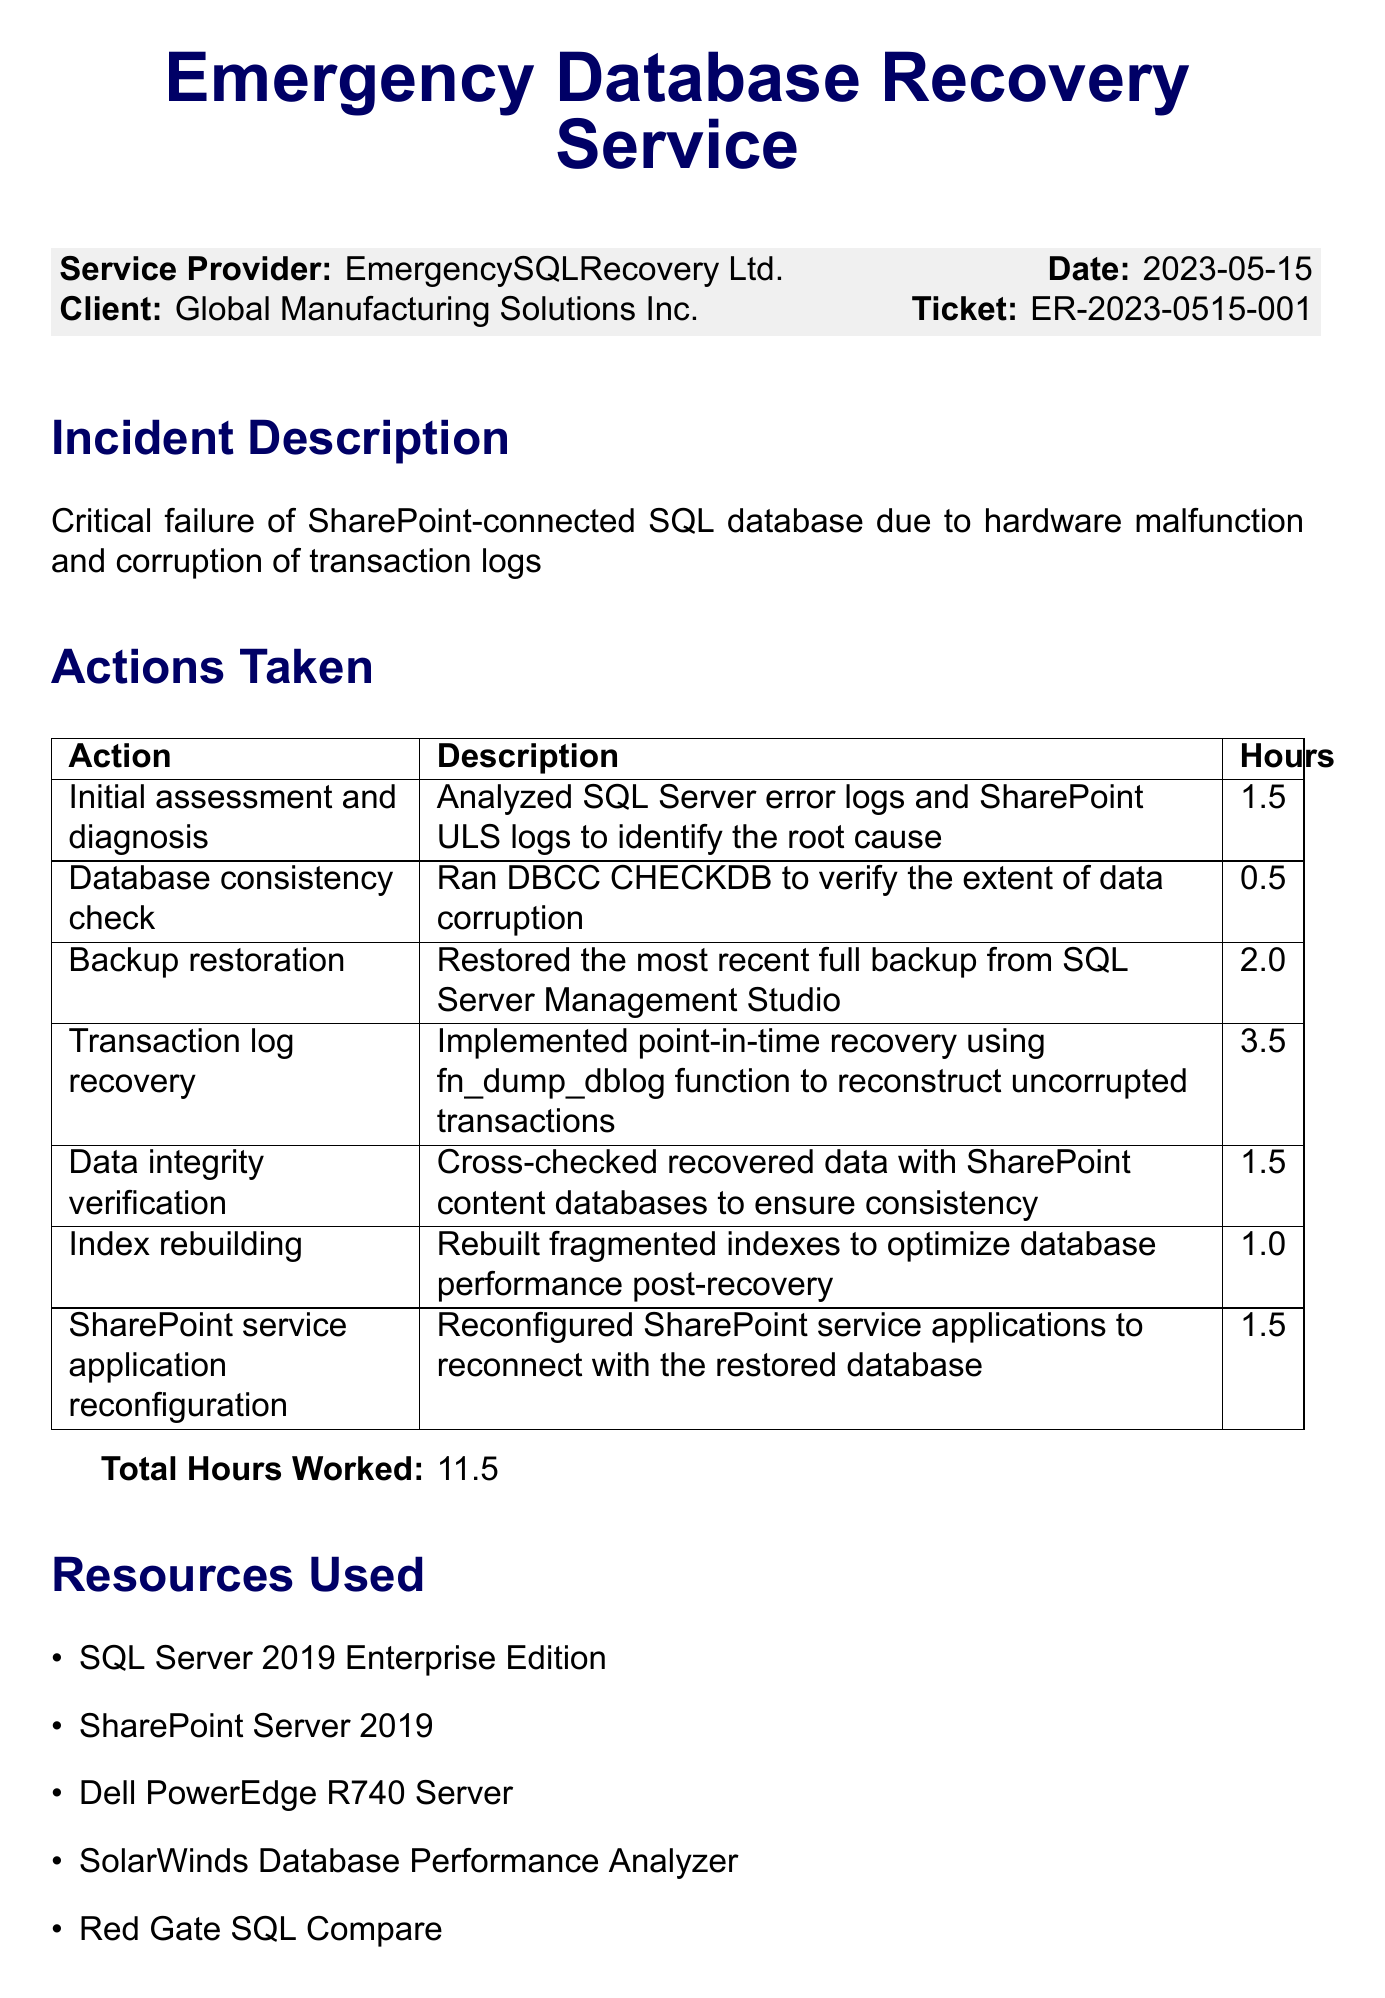What is the service provider's name? The service provider's name is stated in the document as "EmergencySQLRecovery Ltd."
Answer: EmergencySQLRecovery Ltd What is the date of service? The date of service is explicitly mentioned in the document as "2023-05-15."
Answer: 2023-05-15 How many total hours were worked during the recovery? The total hours worked can be found in the "Total Hours Worked" section, which sums the hours listed in the actions taken.
Answer: 11.5 What was the outcome of the recovery service? The outcome is summarized in the document, highlighting the success of data recovery with minimal impact.
Answer: Successfully recovered 99.98% of data with minimal impact on SharePoint functionality Which SQL Server version was used? The resources used section specifies the version as "SQL Server 2019 Enterprise Edition."
Answer: SQL Server 2019 Enterprise Edition What action took the most time during the recovery? By comparing the hours worked for each action, "Transaction log recovery" is identified as the action that took the most time.
Answer: Transaction log recovery What is one of the recommendations provided? The recommendations section includes specific advice for future improvements, such as "Implement SQL Server Always On Availability Groups."
Answer: Implement SQL Server Always On Availability Groups for improved disaster recovery What follow-up action is scheduled for 7 days later? The follow-up actions indicate scheduling a health check, specifically mentioning a time frame.
Answer: Schedule a comprehensive database health check in 7 days 